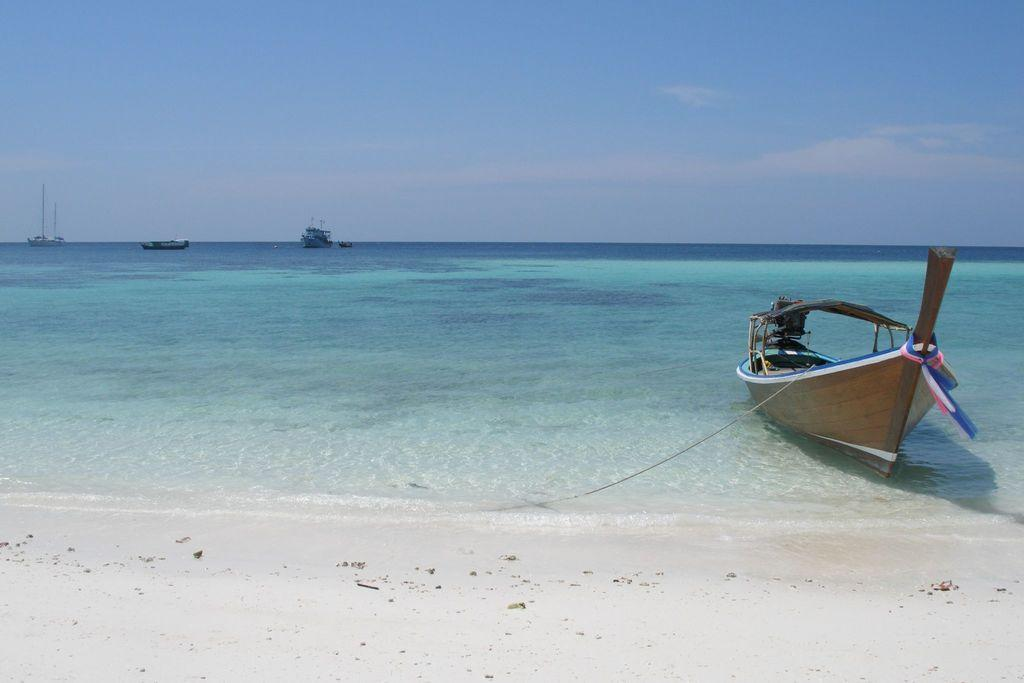What is located on the right side of the image? There is a boat on the right side of the image. What type of terrain is visible at the bottom of the image? There is sand at the bottom of the image. What natural phenomena can be seen in the image? Waves are visible in the image. What is the main substance in the image? There is water in the image. Can you describe the background of the image? There are boats in the background of the image, and the sky is visible with clouds present. What type of tool is the carpenter using to fix the sheet in the image? There is no carpenter or sheet present in the image. What time does the watch show in the image? There is no watch present in the image. 